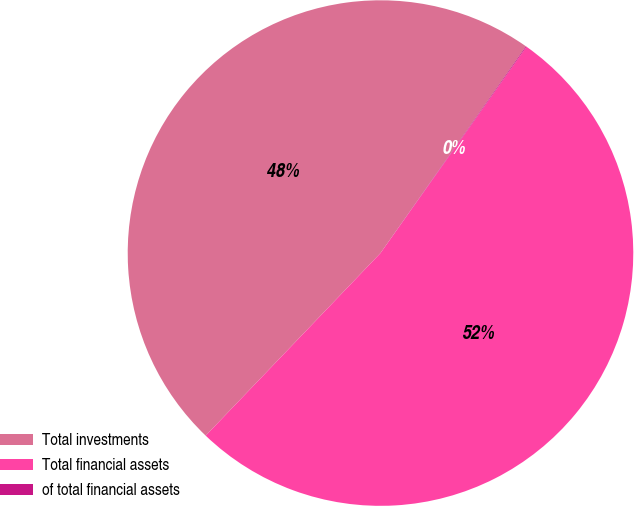Convert chart to OTSL. <chart><loc_0><loc_0><loc_500><loc_500><pie_chart><fcel>Total investments<fcel>Total financial assets<fcel>of total financial assets<nl><fcel>47.6%<fcel>52.35%<fcel>0.05%<nl></chart> 